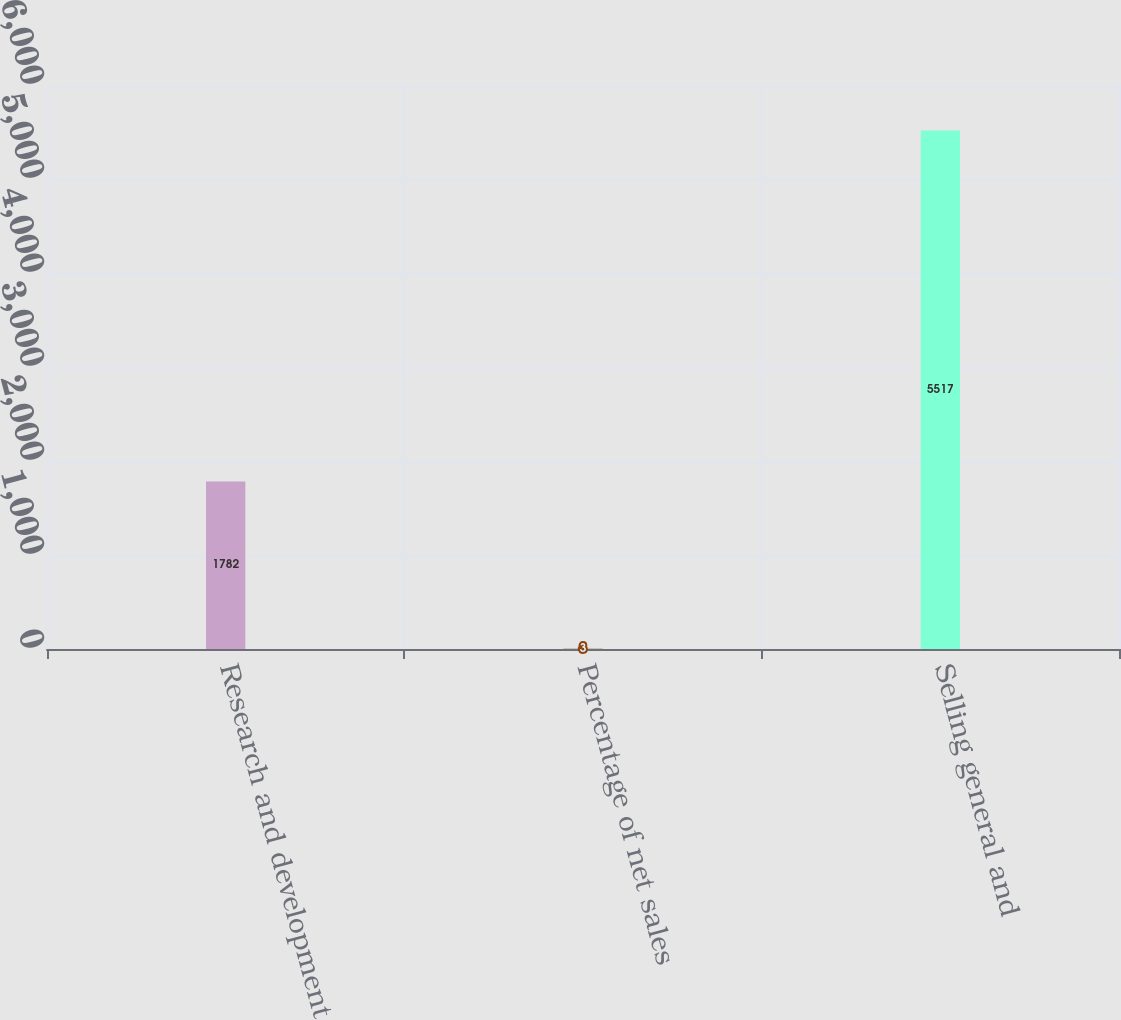Convert chart to OTSL. <chart><loc_0><loc_0><loc_500><loc_500><bar_chart><fcel>Research and development<fcel>Percentage of net sales<fcel>Selling general and<nl><fcel>1782<fcel>3<fcel>5517<nl></chart> 